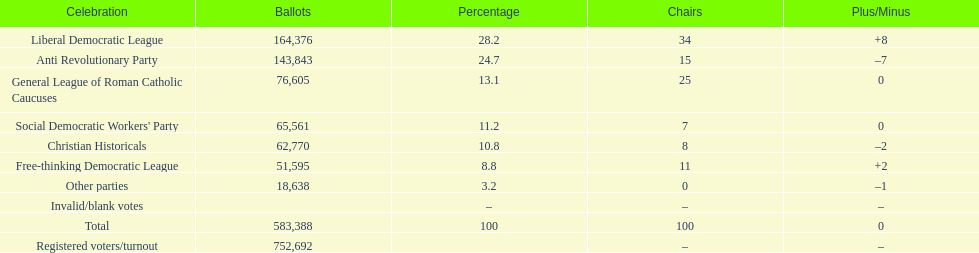How many votes were counted as invalid or blank votes? 0. 